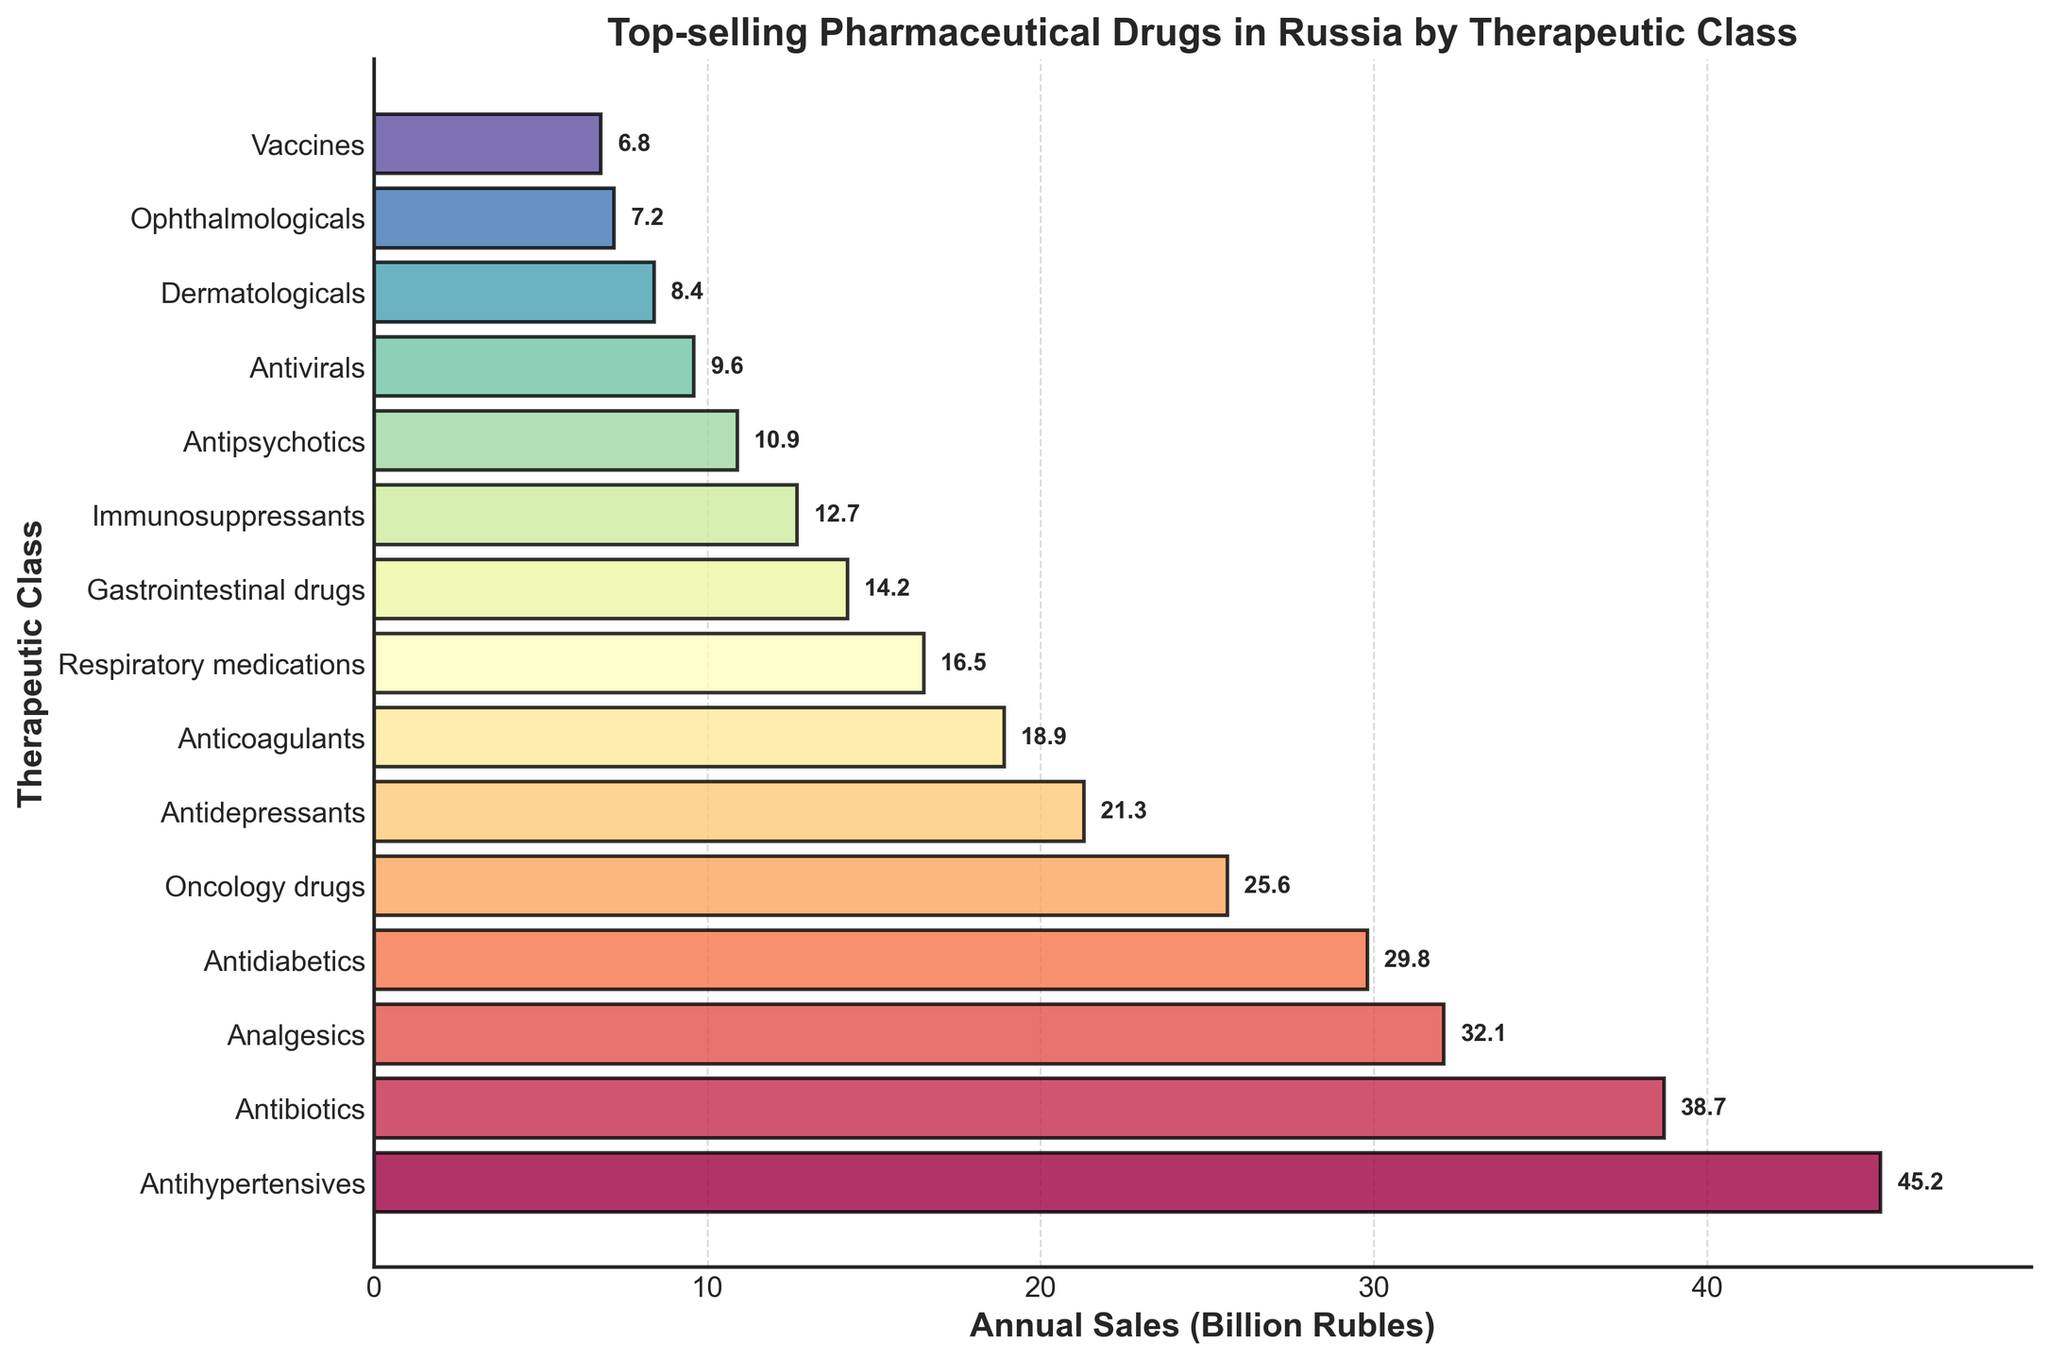Which therapeutic class has the highest annual sales? The bar chart shows the annual sales in billion rubles for different therapeutic classes. By comparing the lengths of the bars, the longest bar represents the therapeutic class with the highest sales, which is Antihypertensives.
Answer: Antihypertensives Which therapeutic class has the lowest annual sales? By comparing the lengths of the bars, the shortest bar represents the therapeutic class with the lowest sales, which is Vaccines.
Answer: Vaccines How much more do Antihypertensives sell compared to Antidepressants? To find the difference in sales between Antihypertensives and Antidepressants, subtract the annual sales of Antidepressants from that of Antihypertensives: 45.2 - 21.3 = 23.9 billion rubles.
Answer: 23.9 billion rubles What is the combined annual sales of Antibiotics and Antidiabetics? To find the total sales for Antibiotics and Antidiabetics, add their respective annual sales: 38.7 + 29.8 = 68.5 billion rubles.
Answer: 68.5 billion rubles Which therapeutic class has nearly half the annual sales of Antihypertensives? First, identify the annual sales of Antihypertensives, which is 45.2 billion rubles. Then, look for a bar that represents sales close to 22.6 billion rubles (half of 45.2). The closest match is Anticoagulants with 18.9 billion rubles.
Answer: Anticoagulants Between Oncology drugs and Antidiabetics, which class has higher annual sales and by how much? Compare the annual sales of Oncology drugs (25.6 billion rubles) and Antidiabetics (29.8 billion rubles). Antidiabetics have higher sales. To find the difference, subtract the sales of Oncology drugs from Antidiabetics: 29.8 - 25.6 = 4.2 billion rubles.
Answer: Antidiabetics, 4.2 billion rubles What is the total annual sales for the top three therapeutic classes? The top three therapeutic classes by sales are Antihypertensives, Antibiotics, and Analgesics. Sum their annual sales: 45.2 + 38.7 + 32.1 = 116 billion rubles.
Answer: 116 billion rubles By how much do the combined sales of Respiratory medications and Gastrointestinal drugs fall short of Analgesics? First, find the combined sales for Respiratory medications and Gastrointestinal drugs: 16.5 + 14.2 = 30.7 billion rubles. Then, subtract this from the sales of Analgesics: 32.1 - 30.7 = 1.4 billion rubles.
Answer: 1.4 billion rubles What is the average annual sales for all therapeutic classes shown in the chart? To find the average, sum all the annual sales and divide by the number of classes. There are 15 classes. Sum: 45.2 + 38.7 + 32.1 + 29.8 + 25.6 + 21.3 + 18.9 + 16.5 + 14.2 + 12.7 + 10.9 + 9.6 + 8.4 + 7.2 + 6.8 = 298 billion rubles. Average: 298 / 15 ≈ 19.87 billion rubles.
Answer: 19.87 billion rubles Which therapeutic class's bar is the third largest in the chart? The third largest bar corresponds to the third highest annual sales, which in this case is Analgesics with 32.1 billion rubles.
Answer: Analgesics 